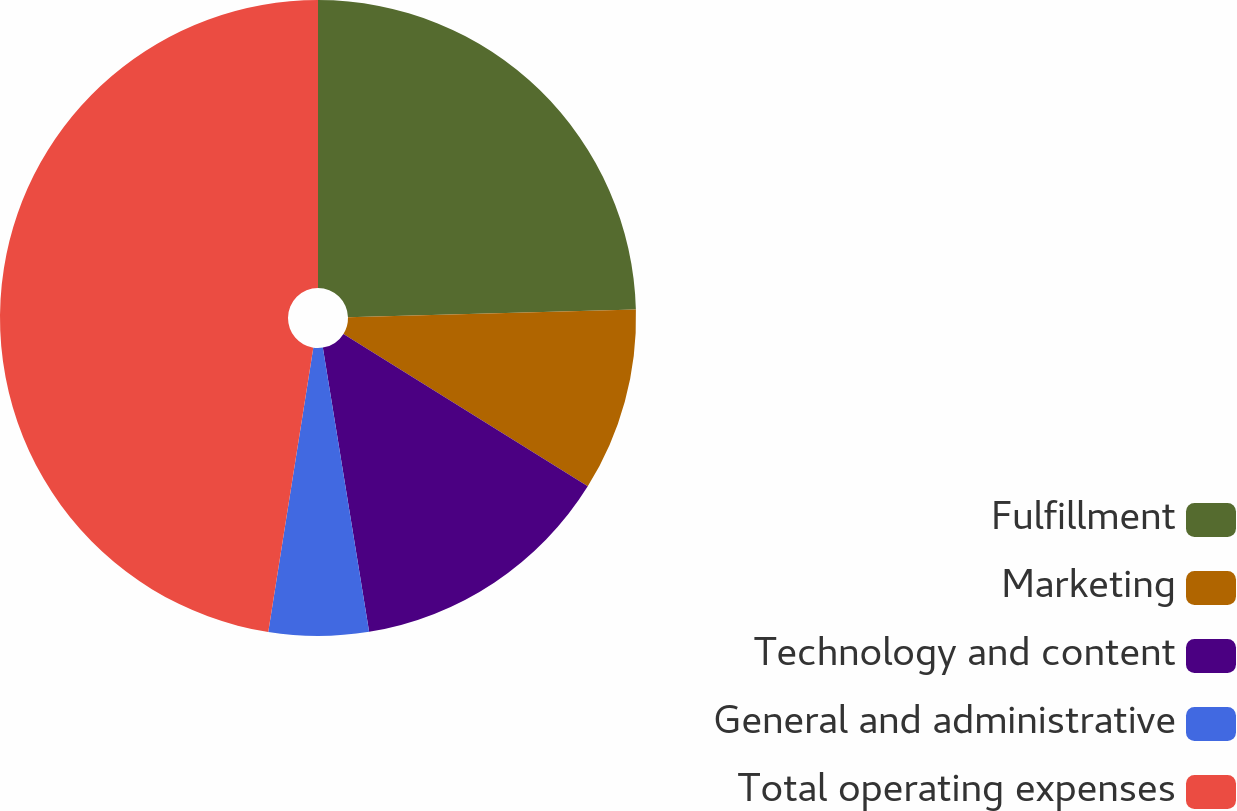Convert chart to OTSL. <chart><loc_0><loc_0><loc_500><loc_500><pie_chart><fcel>Fulfillment<fcel>Marketing<fcel>Technology and content<fcel>General and administrative<fcel>Total operating expenses<nl><fcel>24.57%<fcel>9.31%<fcel>13.55%<fcel>5.07%<fcel>47.5%<nl></chart> 